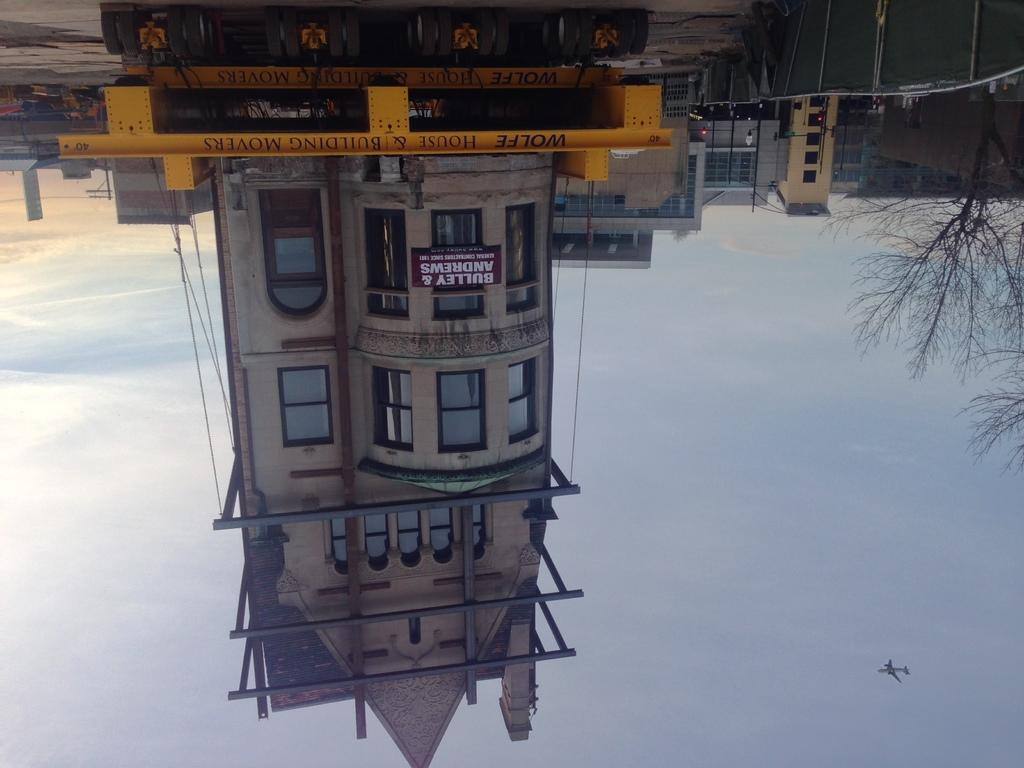What type of structure is visible in the image? There is a building in the image. What other natural elements can be seen in the image? There are trees in the image. What is happening in the sky in the image? There is an airplane flying in the air in the image. Where is the drum located in the image? There is no drum present in the image. What type of yam is growing near the building in the image? There is no yam present in the image. 